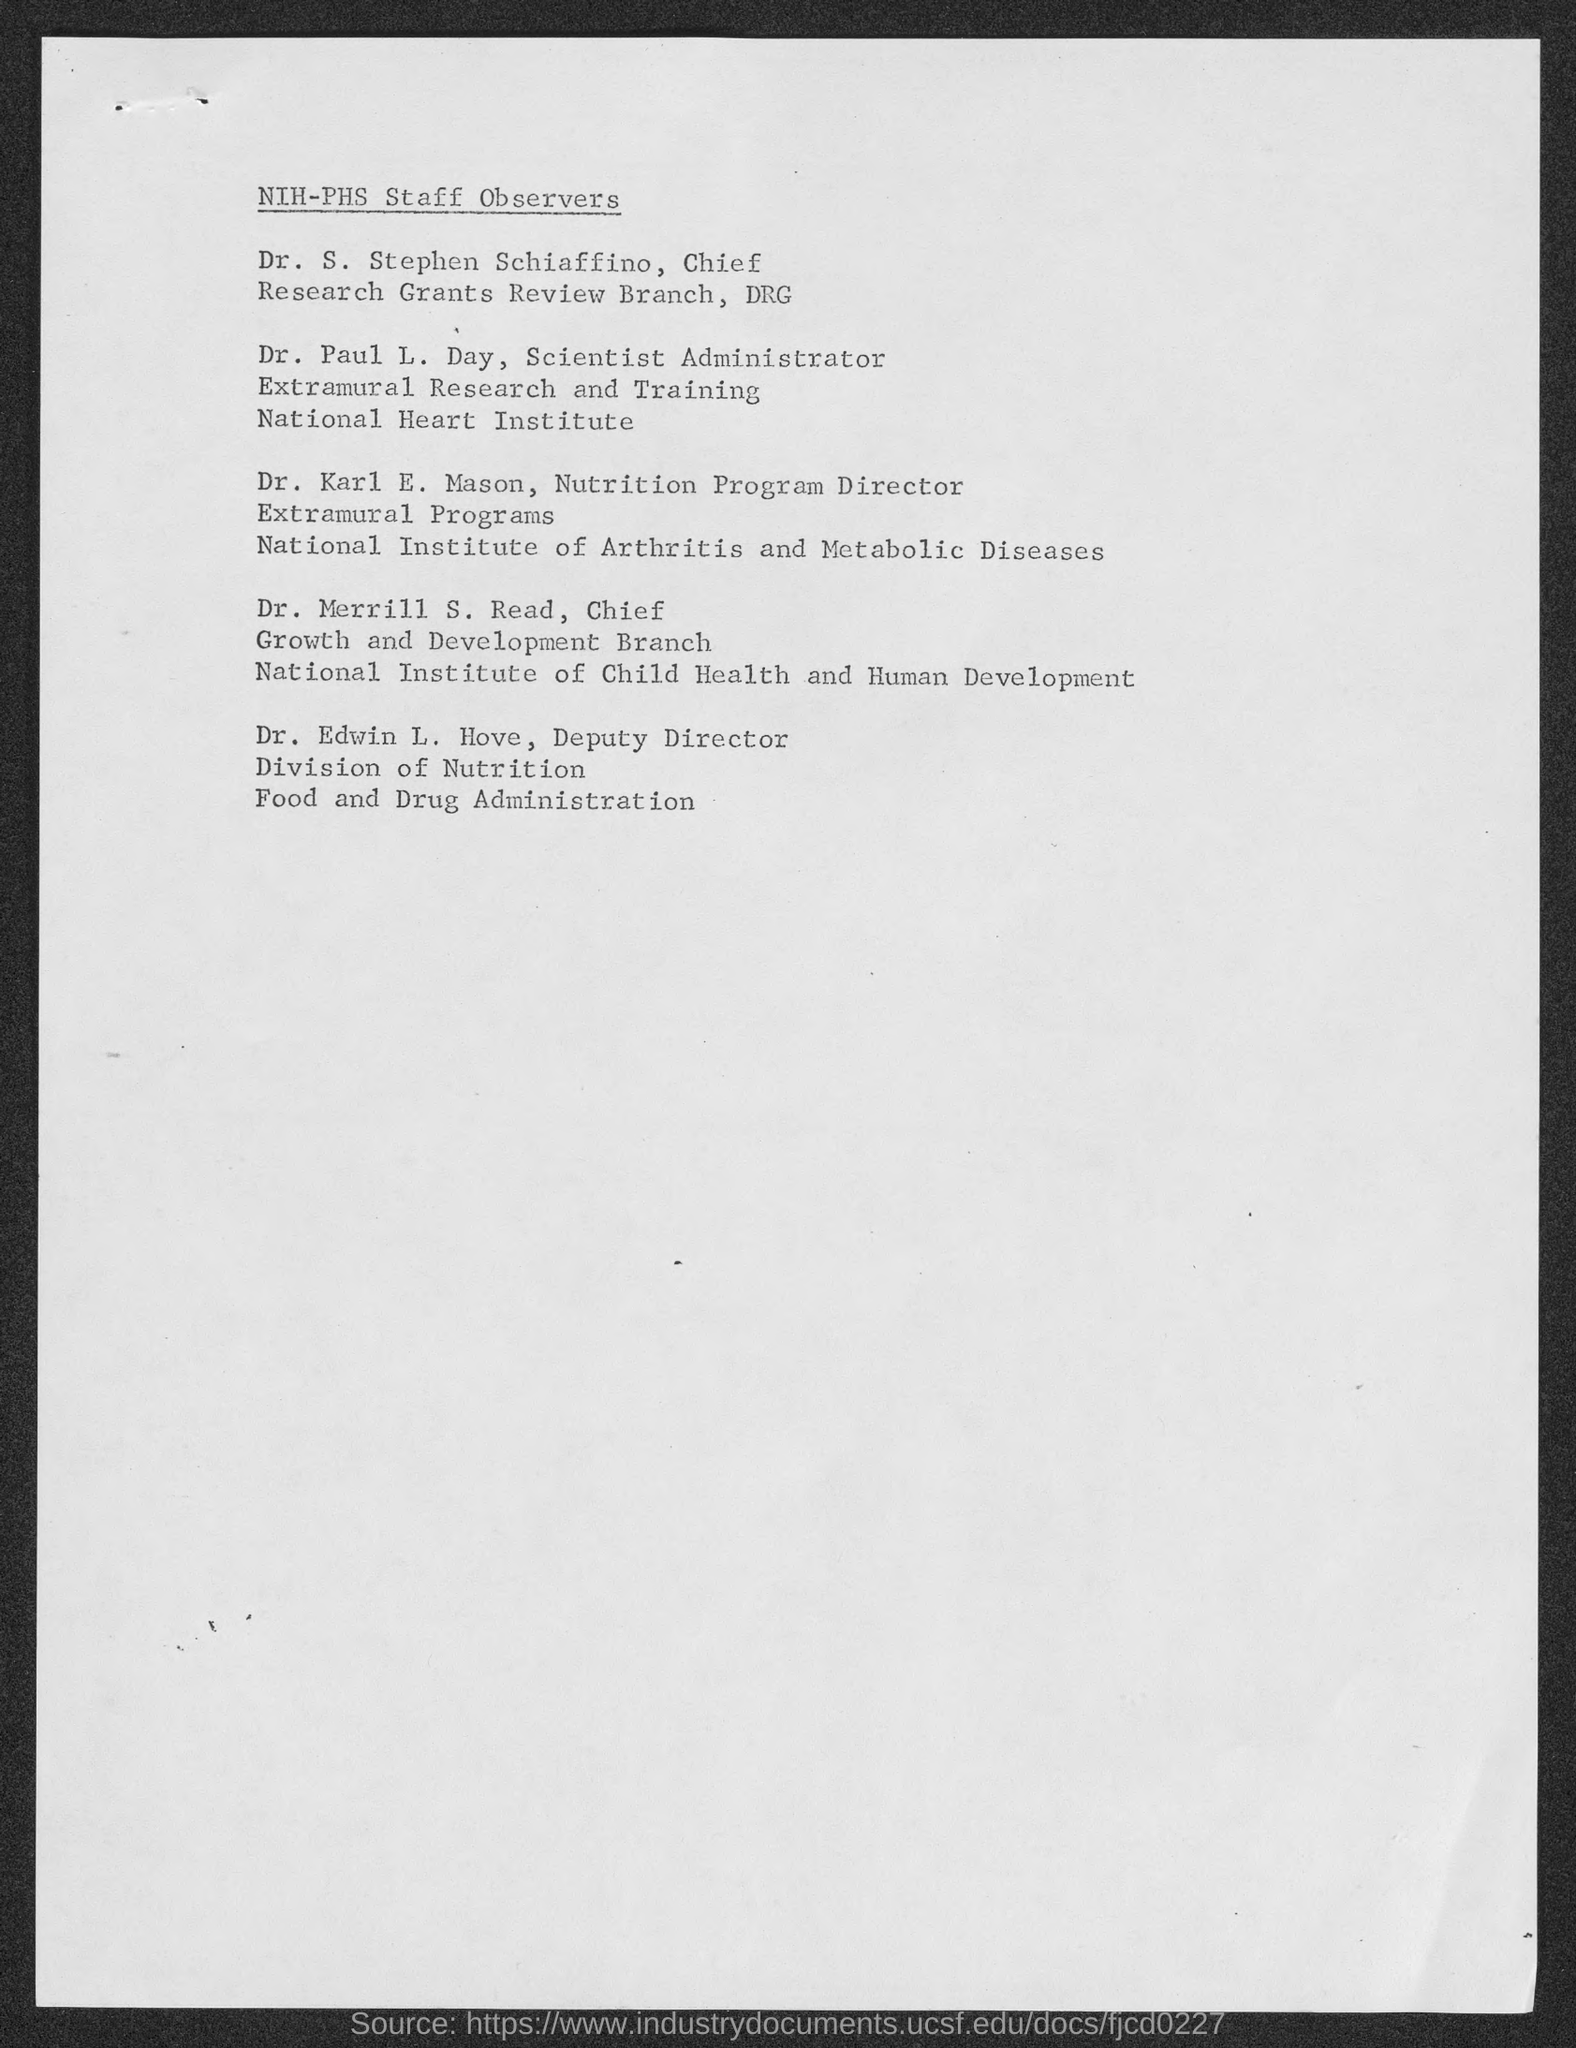Point out several critical features in this image. The scientist administrator named Dr. Paul L. Day is the Extramural Research and Training specialist. DR. S. STEPHEN SCHIAFFINO is the Chief of the Research Grants Review Branch at DRG. The heading of this document is 'NIH-PHS Staff Observers.' 